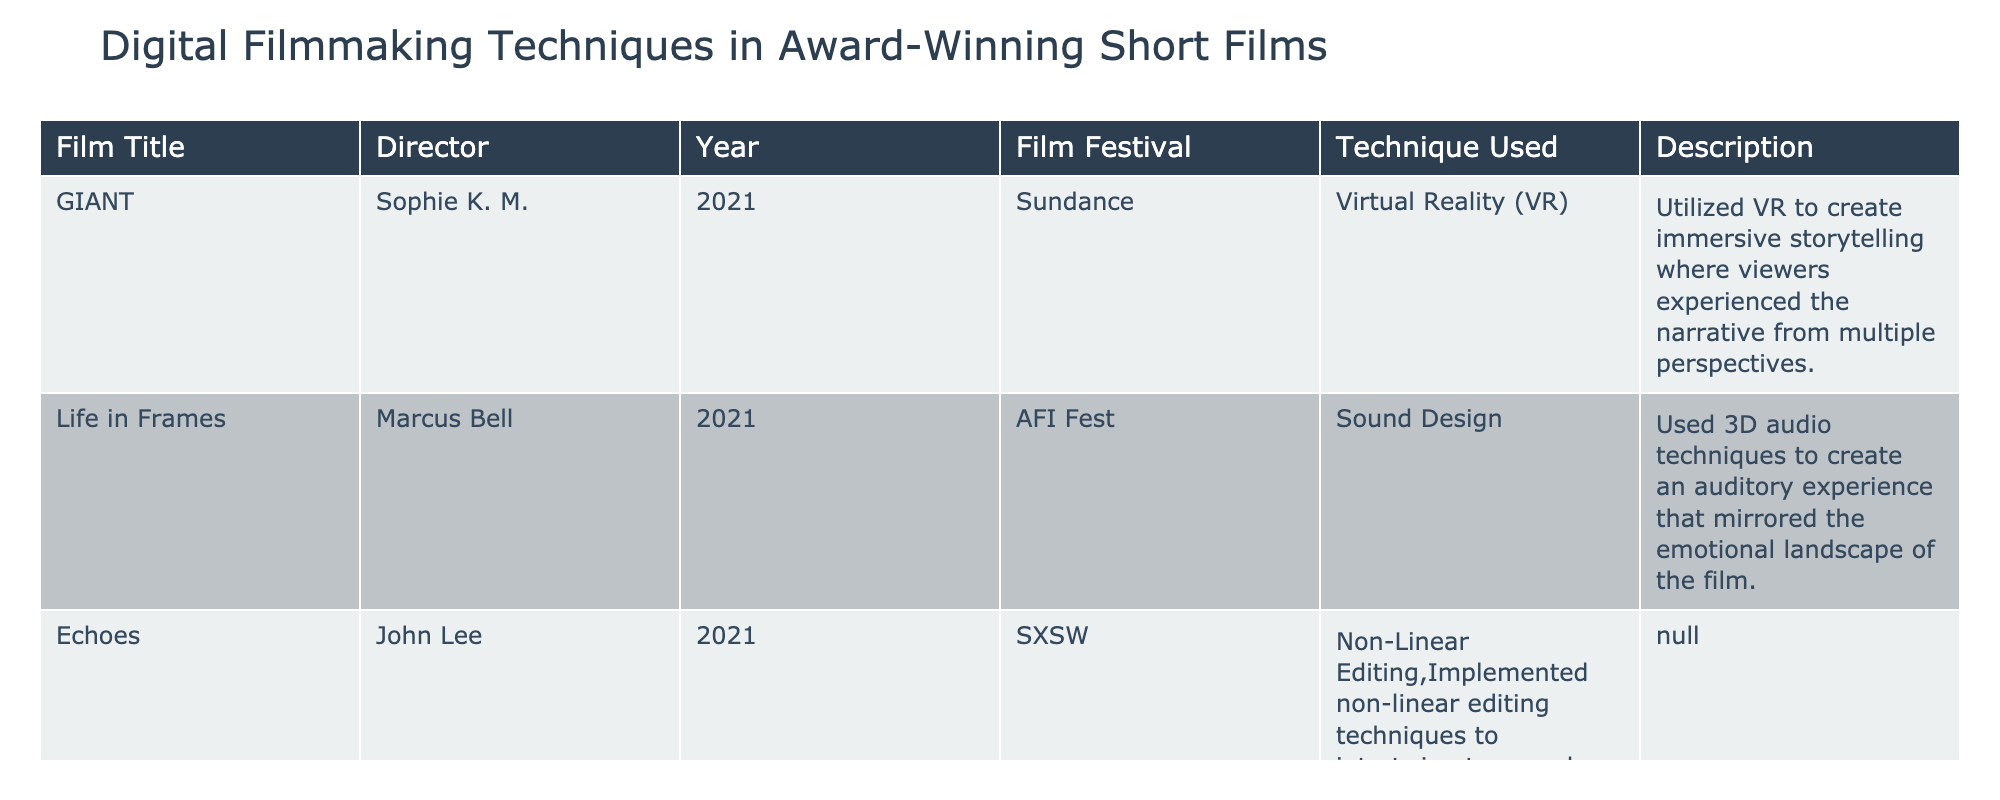What is the title of the film that utilized Virtual Reality? The table shows that "GIANT" is the film that used Virtual Reality as a technique.
Answer: "GIANT" How many films in total were released in 2021? The table lists three films released in 2021: "GIANT", "Life in Frames", and "Echoes". Therefore, the total is 3.
Answer: 3 Did "Resonance" use Non-Linear Editing? The table indicates that "Resonance" used Digital Color Grading, not Non-Linear Editing. Hence, the answer is false.
Answer: False Which film applied advanced digital color grading tools? According to the table, "Resonance" applied advanced digital color grading tools to enhance the film's mood and style.
Answer: "Resonance" What is the technique used in "Life in Frames"? The table specifies that "Life in Frames" used sound design, specifically 3D audio techniques.
Answer: Sound Design Among the listed films, which has the longest title? By comparing the titles in the table, "Life in Frames" has the longest title with 14 characters (including spaces).
Answer: "Life in Frames" Which film festival featured the movie "Echoes"? The data indicates that "Echoes" was featured at the SXSW film festival.
Answer: SXSW How many different film festivals are represented in this table? The table lists four different film festivals: Sundance, AFI Fest, SXSW, and BAFTA. Therefore, the total is 4.
Answer: 4 Which two films were directed by an individual named "Sophie K. M."? The data shows that only one film, "GIANT", was directed by Sophie K. M., so the answer indicates there are no two films.
Answer: 1 